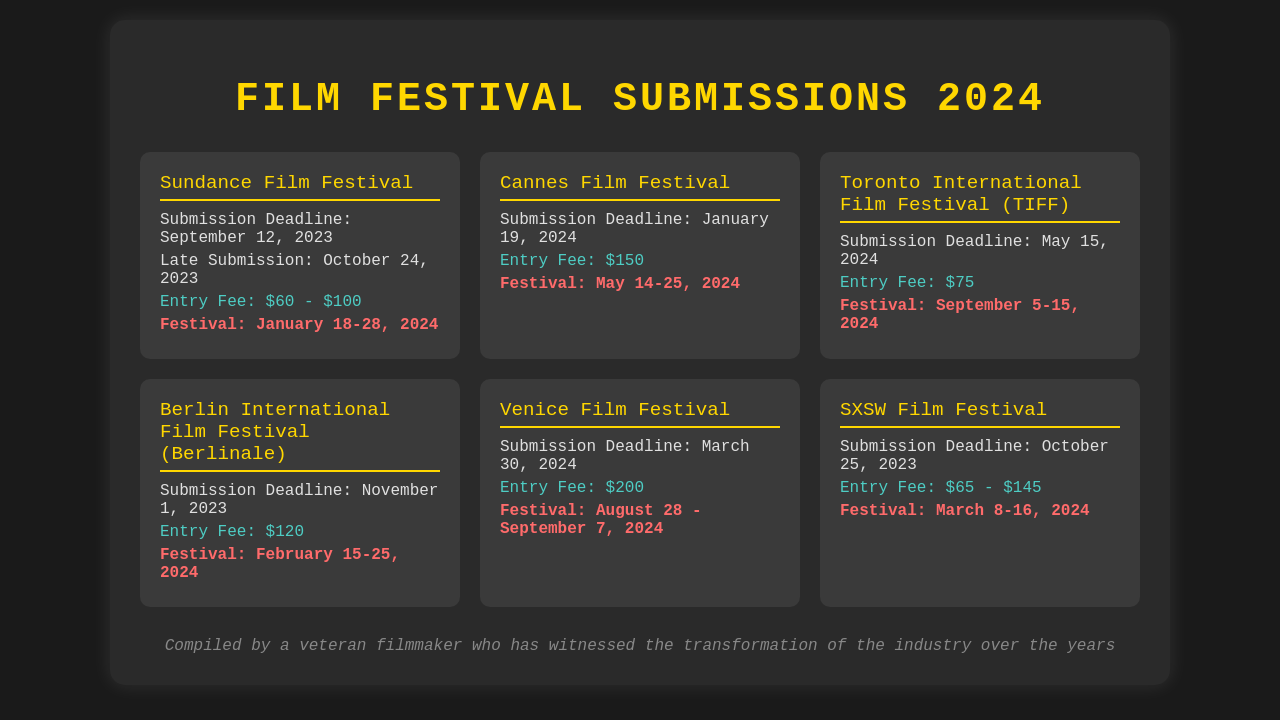What is the submission deadline for Sundance Film Festival? The submission deadline is listed directly in the document for the Sundance Film Festival.
Answer: September 12, 2023 What is the entry fee for the Cannes Film Festival? The entry fee for the Cannes Film Festival is stated clearly in the document.
Answer: $150 When does the Toronto International Film Festival take place? The festival dates for TIFF are mentioned in the corresponding section of the document.
Answer: September 5-15, 2024 What is the late submission deadline for Sundance Film Festival? The late submission deadline is provided in the information related to Sundance Film Festival.
Answer: October 24, 2023 Which festival has the highest entry fee? By comparing entry fees from all listed festivals, we identify the one with the highest fee.
Answer: Venice Film Festival: $200 What is the total number of festivals listed in the document? The total number of festival entries can be counted from the grid in the document.
Answer: 6 Which festival has its submission deadline closest to today? By evaluating the submission deadlines, we identify which one is nearest to the current date.
Answer: Berlin International Film Festival: November 1, 2023 What color is used for the festival names? The document explicitly mentions the color used for festival names in its styling.
Answer: Gold What is the festival date for SXSW Film Festival? The festival dates are explicitly listed for SXSW Film Festival in the document.
Answer: March 8-16, 2024 